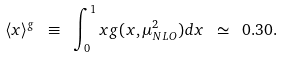<formula> <loc_0><loc_0><loc_500><loc_500>\langle x \rangle ^ { g } \ \equiv \ \int _ { 0 } ^ { 1 } x g ( x , \mu _ { N L O } ^ { 2 } ) d x \ \simeq \ 0 . 3 0 .</formula> 